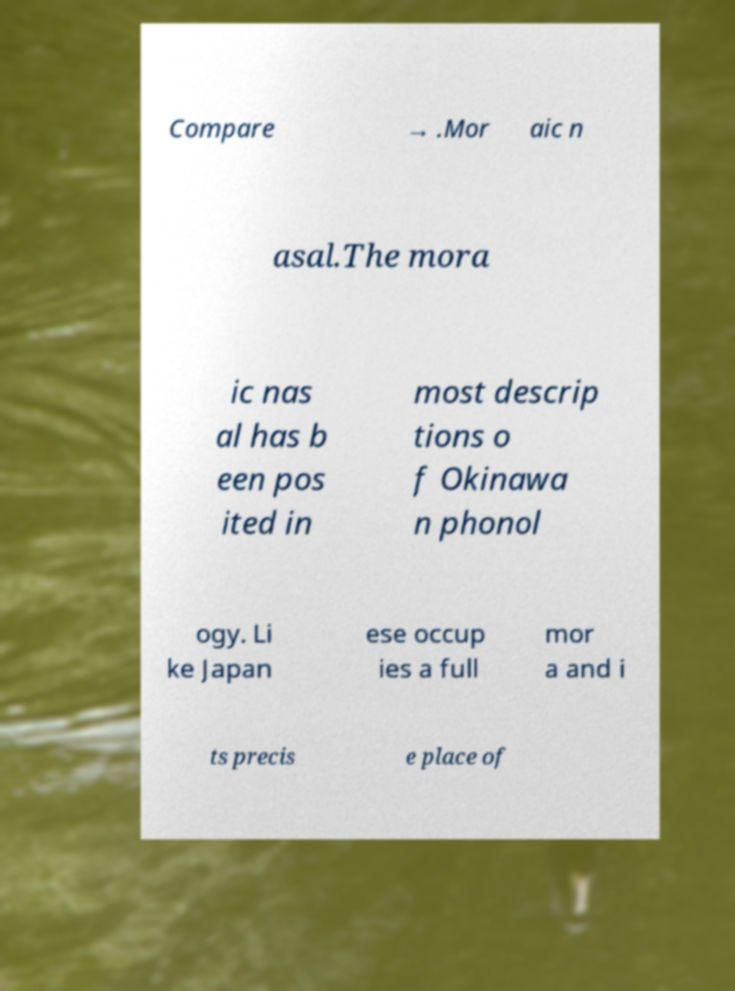I need the written content from this picture converted into text. Can you do that? Compare → .Mor aic n asal.The mora ic nas al has b een pos ited in most descrip tions o f Okinawa n phonol ogy. Li ke Japan ese occup ies a full mor a and i ts precis e place of 